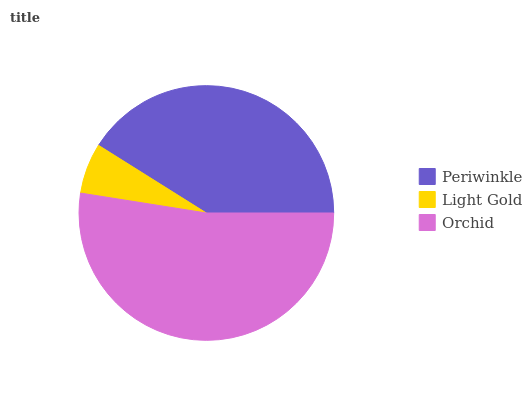Is Light Gold the minimum?
Answer yes or no. Yes. Is Orchid the maximum?
Answer yes or no. Yes. Is Orchid the minimum?
Answer yes or no. No. Is Light Gold the maximum?
Answer yes or no. No. Is Orchid greater than Light Gold?
Answer yes or no. Yes. Is Light Gold less than Orchid?
Answer yes or no. Yes. Is Light Gold greater than Orchid?
Answer yes or no. No. Is Orchid less than Light Gold?
Answer yes or no. No. Is Periwinkle the high median?
Answer yes or no. Yes. Is Periwinkle the low median?
Answer yes or no. Yes. Is Orchid the high median?
Answer yes or no. No. Is Orchid the low median?
Answer yes or no. No. 